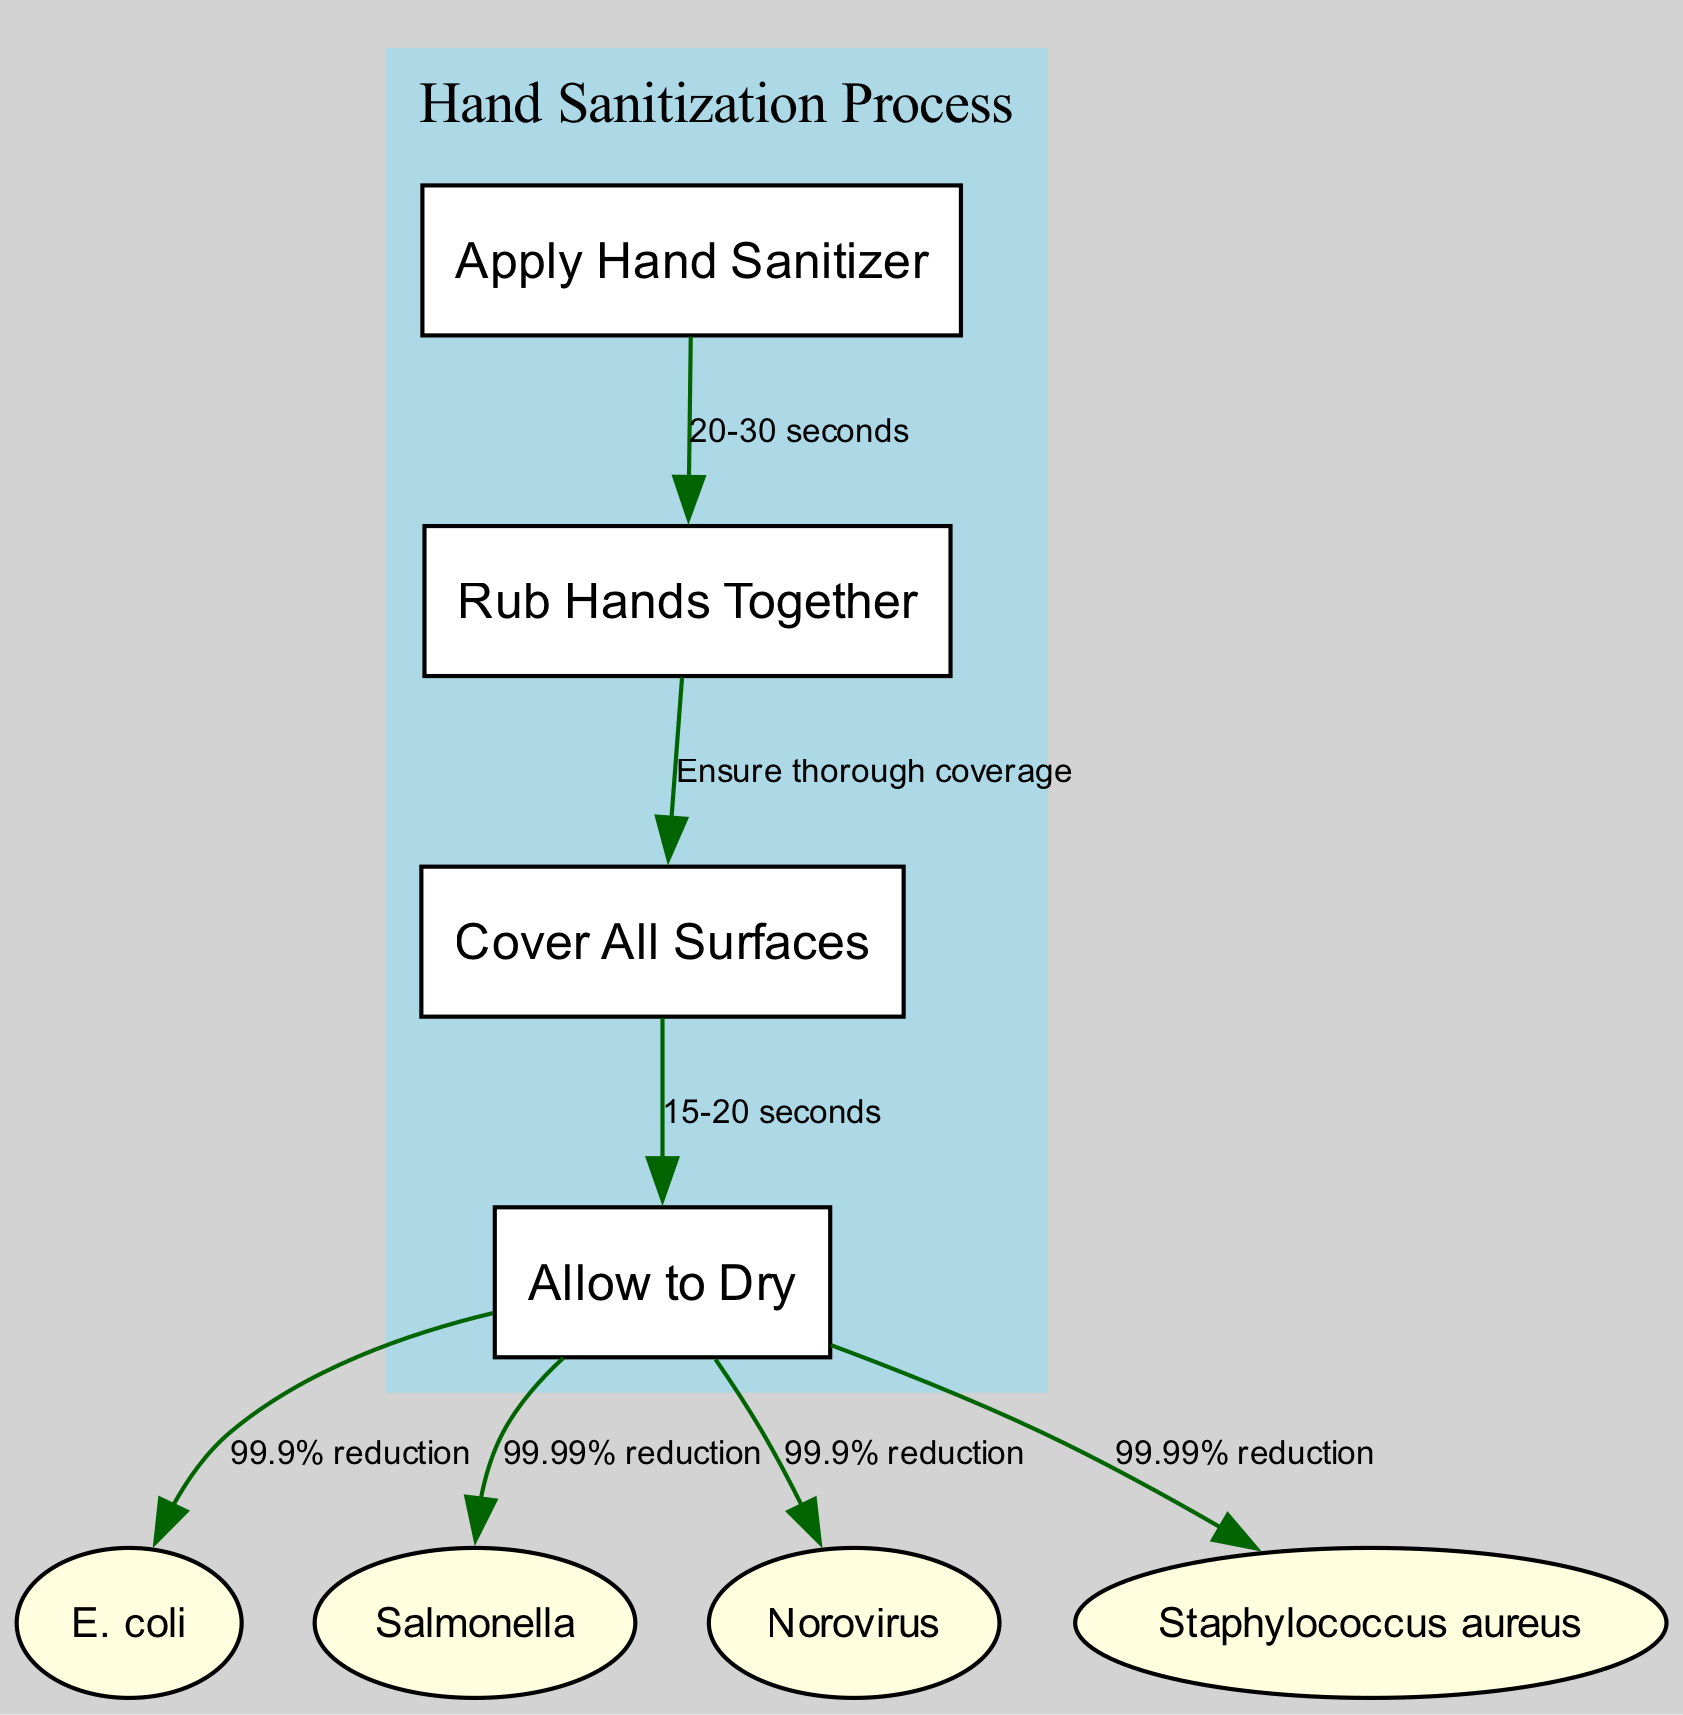What is the first step in the hand sanitization process? According to the diagram, the first step is labeled as "Apply Hand Sanitizer," indicating that this action initiates the hand sanitization process.
Answer: Apply Hand Sanitizer How long should hands be rubbed together? The edge connecting "Apply Hand Sanitizer" to "Rub Hands Together" states "20-30 seconds," which indicates the recommended duration for this action.
Answer: 20-30 seconds What is a key action to ensure during the hand sanitization process? The diagram specifies under the connection between "Rub Hands Together" and "Cover All Surfaces" that one should "Ensure thorough coverage." This highlights the importance of covering all areas.
Answer: Ensure thorough coverage How long should the hands be allowed to dry? Following the action "Allow to Dry," the diagram does not directly show the time but implies the finalization of the sanitization process without a specific duration listed for drying.
Answer: Not specified Which microorganism has a 99.99% reduction after hand sanitization? The node "Salmonella" shows a connection to "Allow to Dry" stating "99.99% reduction," indicating its effectiveness after following the sanitization steps.
Answer: Salmonella What percentage reduction is achieved for Staphylococcus aureus? The diagram indicates that after "Allow to Dry," there is a "99.99% reduction," specifically noted for Staphylococcus aureus.
Answer: 99.99% reduction How many microorganisms are listed in the diagram? By counting the nodes labeled as microorganisms (E. coli, Salmonella, Norovirus, Staphylococcus aureus), there are four distinct microorganisms shown in the diagram.
Answer: Four What are the microorganisms addressed in the diagram? The diagram lists "E. coli," "Salmonella," "Norovirus," and "Staphylococcus aureus" as the relevant microorganisms focused on in the context of hand sanitization effectiveness.
Answer: E. coli, Salmonella, Norovirus, Staphylococcus aureus What is the overall effectiveness of hand sanitization for Norovirus? The diagram indicates under the connection to "Allow to Dry" that the reduction for Norovirus is "99.9%," detailing its effectiveness in reducing the microorganism presence.
Answer: 99.9% reduction 